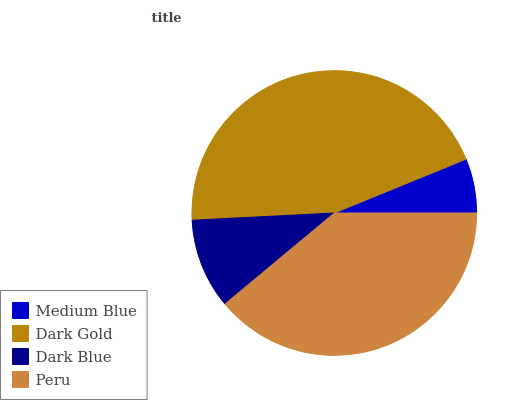Is Medium Blue the minimum?
Answer yes or no. Yes. Is Dark Gold the maximum?
Answer yes or no. Yes. Is Dark Blue the minimum?
Answer yes or no. No. Is Dark Blue the maximum?
Answer yes or no. No. Is Dark Gold greater than Dark Blue?
Answer yes or no. Yes. Is Dark Blue less than Dark Gold?
Answer yes or no. Yes. Is Dark Blue greater than Dark Gold?
Answer yes or no. No. Is Dark Gold less than Dark Blue?
Answer yes or no. No. Is Peru the high median?
Answer yes or no. Yes. Is Dark Blue the low median?
Answer yes or no. Yes. Is Dark Blue the high median?
Answer yes or no. No. Is Peru the low median?
Answer yes or no. No. 